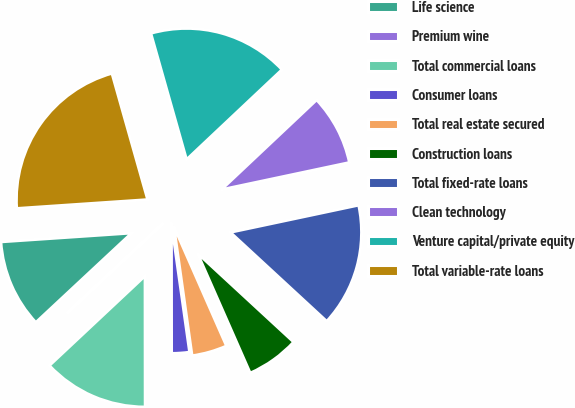Convert chart to OTSL. <chart><loc_0><loc_0><loc_500><loc_500><pie_chart><fcel>Life science<fcel>Premium wine<fcel>Total commercial loans<fcel>Consumer loans<fcel>Total real estate secured<fcel>Construction loans<fcel>Total fixed-rate loans<fcel>Clean technology<fcel>Venture capital/private equity<fcel>Total variable-rate loans<nl><fcel>10.87%<fcel>0.04%<fcel>13.03%<fcel>2.21%<fcel>4.37%<fcel>6.54%<fcel>15.19%<fcel>8.7%<fcel>17.36%<fcel>21.69%<nl></chart> 